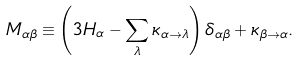Convert formula to latex. <formula><loc_0><loc_0><loc_500><loc_500>M _ { \alpha \beta } \equiv \left ( 3 H _ { \alpha } - \sum _ { \lambda } \kappa _ { \alpha \rightarrow \lambda } \right ) \delta _ { \alpha \beta } + \kappa _ { \beta \rightarrow \alpha } .</formula> 